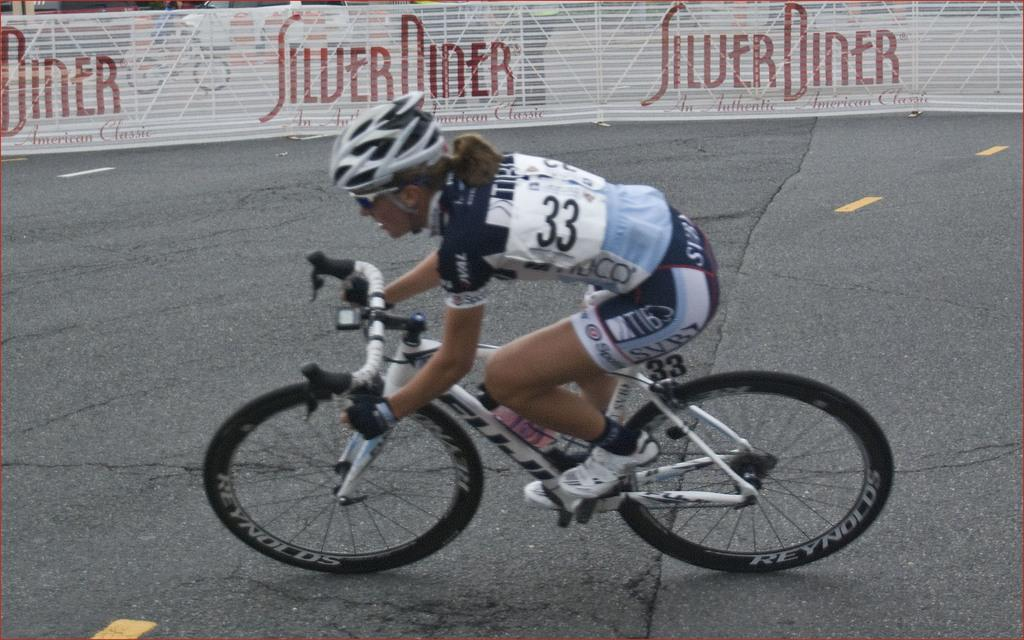Who is the main subject in the image? There is a lady in the image. What type of clothing is the lady wearing? The lady is wearing a sports dress. What activity is the lady engaged in? The lady is riding a bicycle. Where is the bicycle located? The bicycle is on the road. What can be seen in the background of the image? There is a fence in the background of the image. Where is the cannon located in the image? There is no cannon present in the image. What trick is the lady performing while riding the bicycle? The image does not depict any tricks being performed; the lady is simply riding a bicycle. 